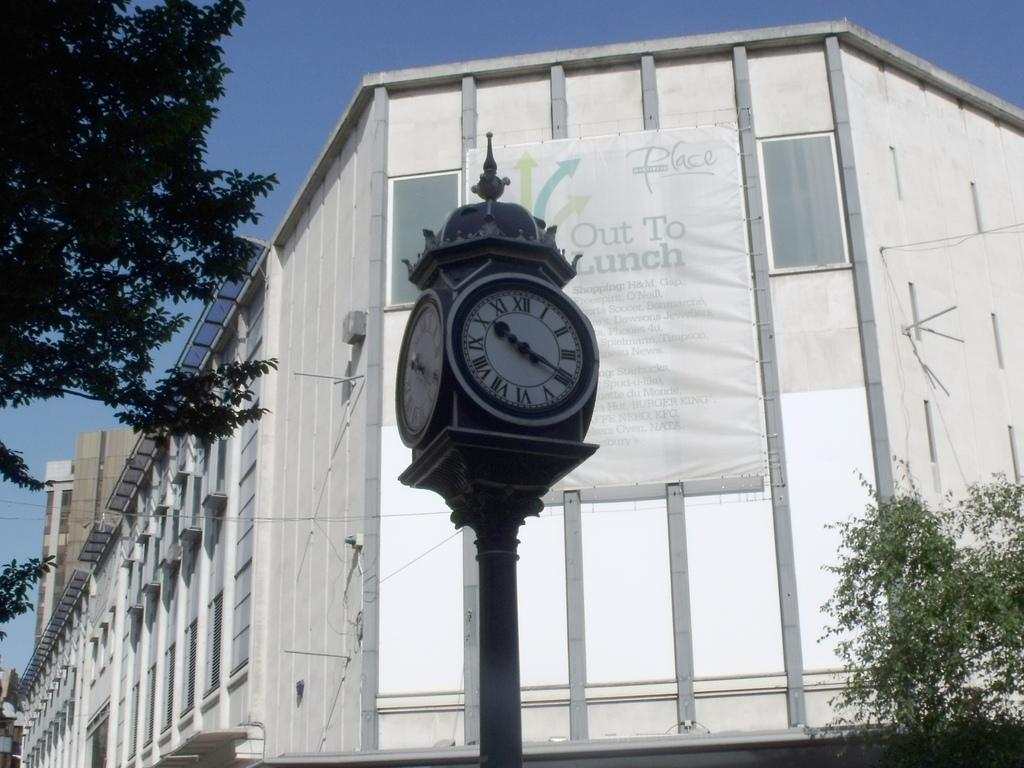<image>
Provide a brief description of the given image. A clock on a street sits in front of a building that says "out to lunch" 